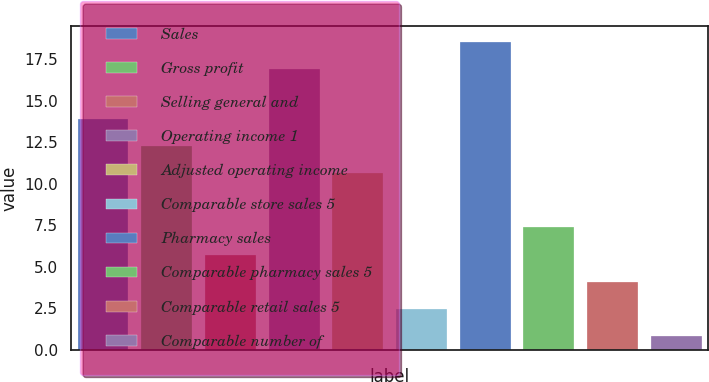Convert chart to OTSL. <chart><loc_0><loc_0><loc_500><loc_500><bar_chart><fcel>Sales<fcel>Gross profit<fcel>Selling general and<fcel>Operating income 1<fcel>Adjusted operating income<fcel>Comparable store sales 5<fcel>Pharmacy sales<fcel>Comparable pharmacy sales 5<fcel>Comparable retail sales 5<fcel>Comparable number of<nl><fcel>13.92<fcel>12.28<fcel>5.72<fcel>16.9<fcel>10.64<fcel>2.44<fcel>18.54<fcel>7.36<fcel>4.08<fcel>0.8<nl></chart> 